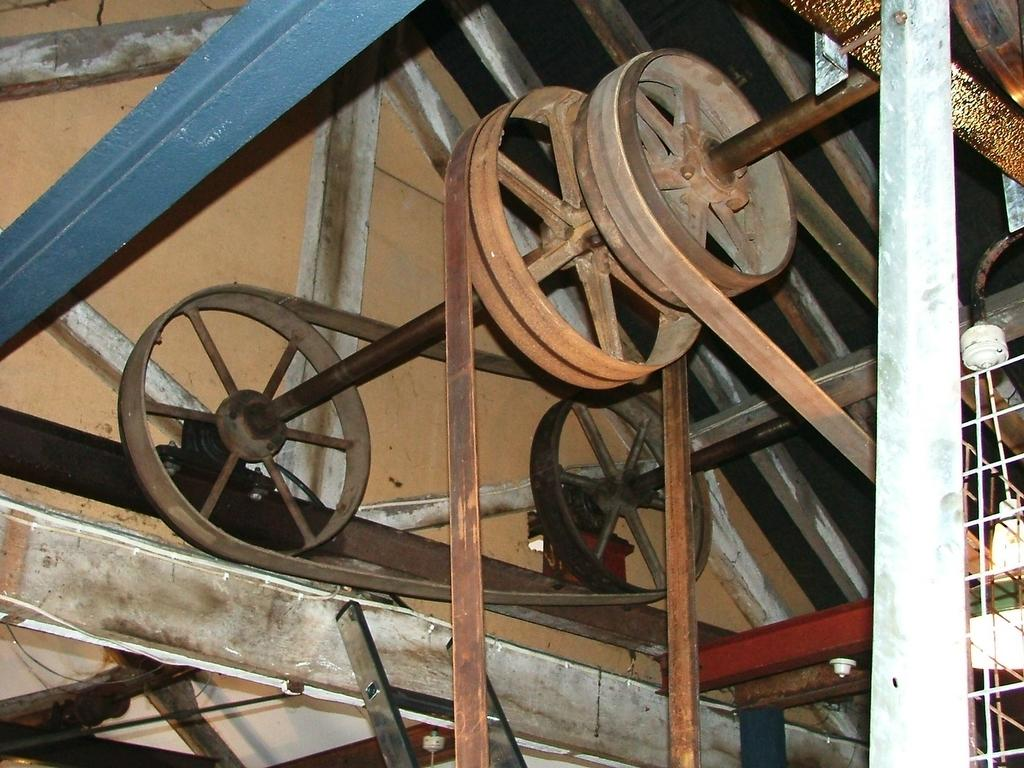What type of space is depicted in the image? The image shows an inner view of a room. What kind of machine can be seen in the room? There is a machine with wheels in the room. Are there any specific features of the machine? Yes, the machine has belts attached to it. What additional feature is present in the room? There is a ladder on the side of the room. What type of cracker is being used to run the machine in the image? There is no cracker present in the image, nor is there any indication that a cracker is being used to run the machine. 